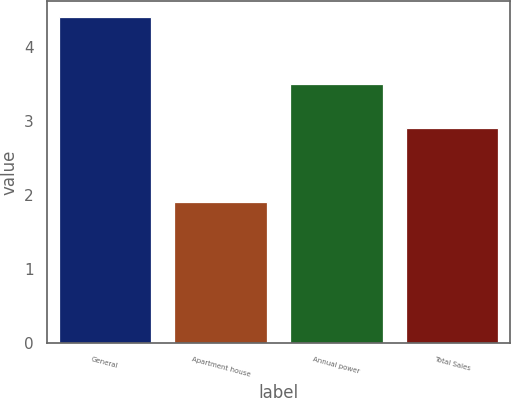Convert chart to OTSL. <chart><loc_0><loc_0><loc_500><loc_500><bar_chart><fcel>General<fcel>Apartment house<fcel>Annual power<fcel>Total Sales<nl><fcel>4.4<fcel>1.9<fcel>3.5<fcel>2.9<nl></chart> 